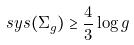<formula> <loc_0><loc_0><loc_500><loc_500>s y s ( \Sigma _ { g } ) \geq \frac { 4 } { 3 } \log g</formula> 